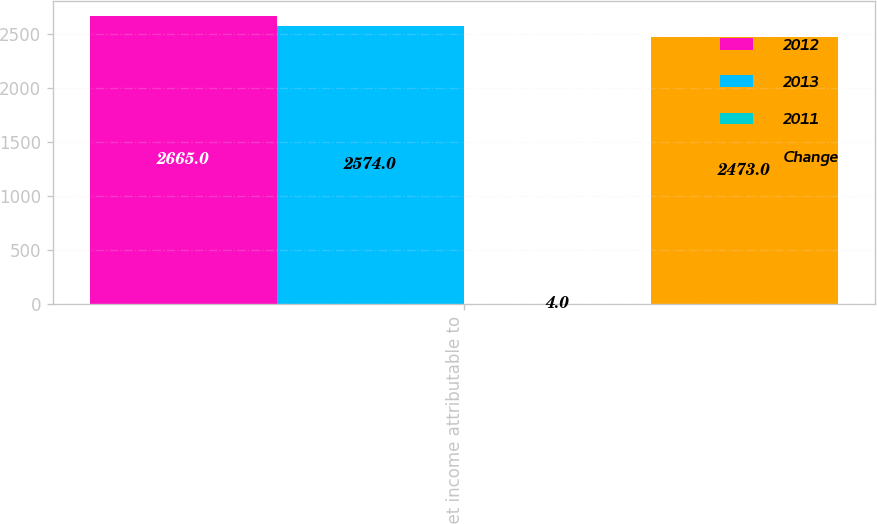<chart> <loc_0><loc_0><loc_500><loc_500><stacked_bar_chart><ecel><fcel>Net income attributable to<nl><fcel>2012<fcel>2665<nl><fcel>2013<fcel>2574<nl><fcel>2011<fcel>4<nl><fcel>Change<fcel>2473<nl></chart> 